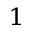<formula> <loc_0><loc_0><loc_500><loc_500>^ { 1 }</formula> 